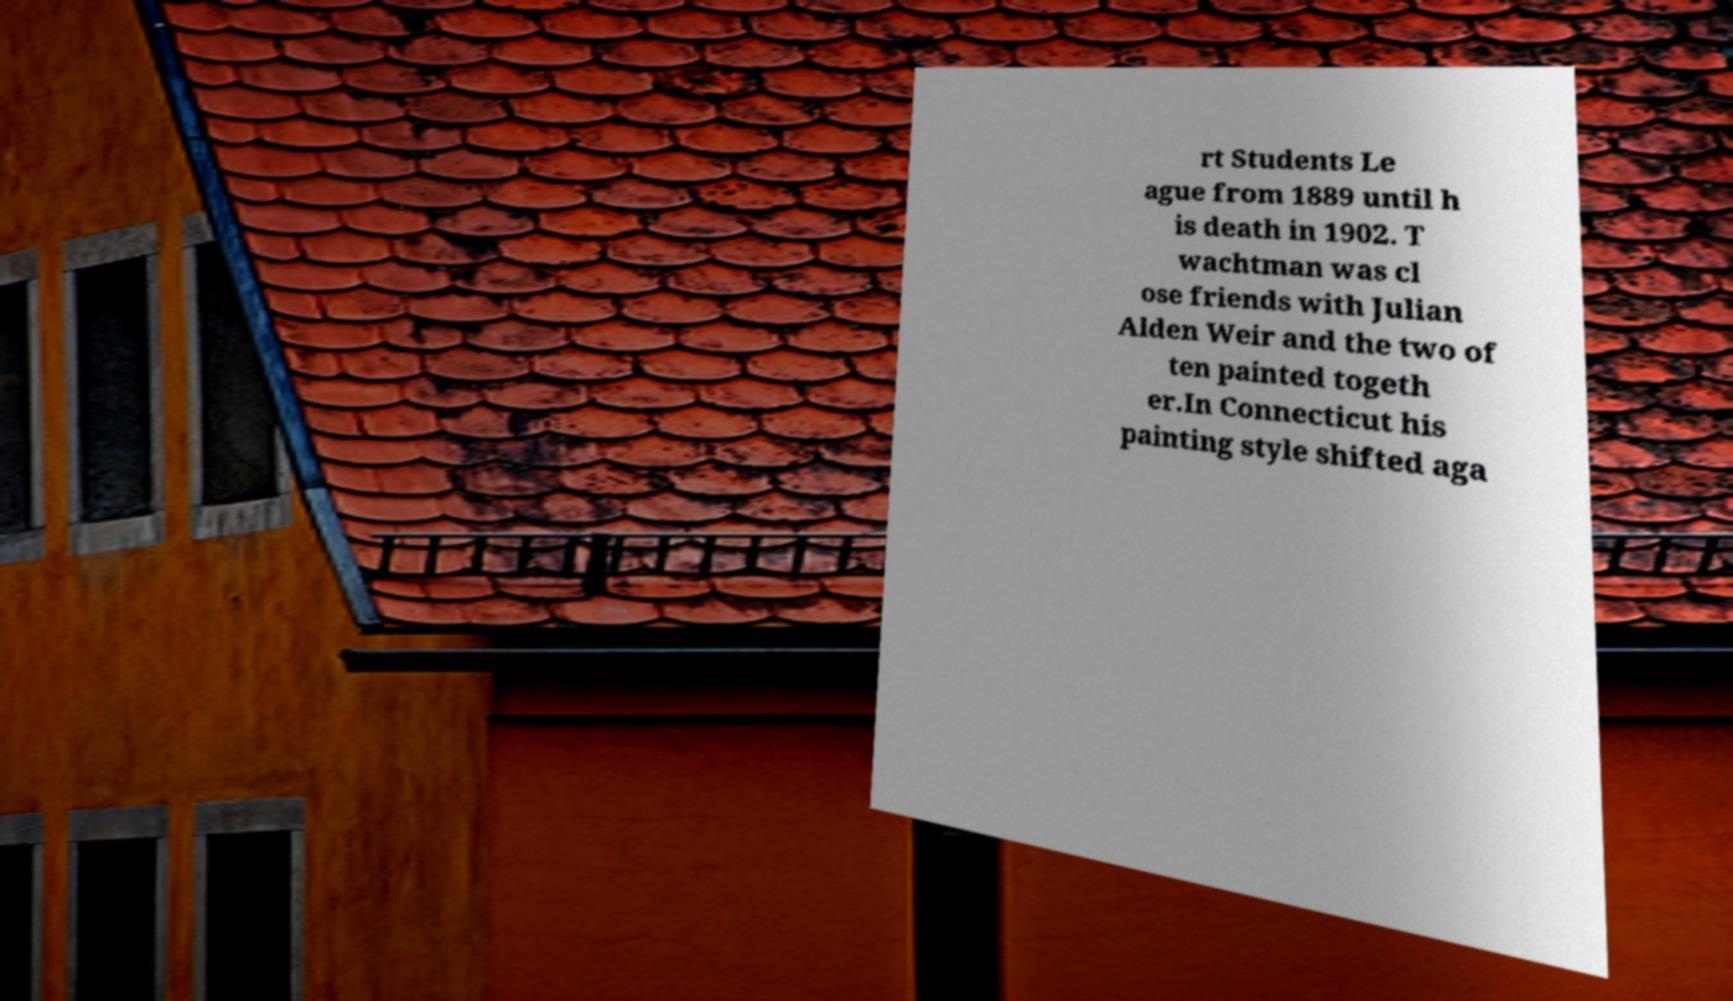Can you accurately transcribe the text from the provided image for me? rt Students Le ague from 1889 until h is death in 1902. T wachtman was cl ose friends with Julian Alden Weir and the two of ten painted togeth er.In Connecticut his painting style shifted aga 